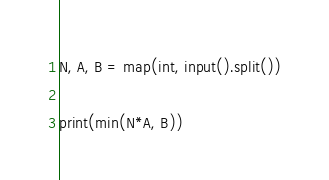Convert code to text. <code><loc_0><loc_0><loc_500><loc_500><_Python_>N, A, B = map(int, input().split())

print(min(N*A, B))
</code> 